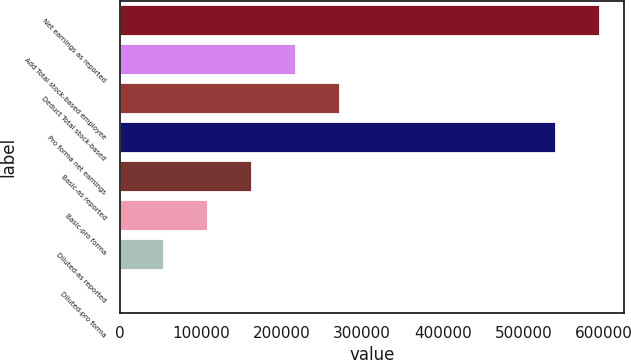<chart> <loc_0><loc_0><loc_500><loc_500><bar_chart><fcel>Net earnings as reported<fcel>Add Total stock-based employee<fcel>Deduct Total stock-based<fcel>Pro forma net earnings<fcel>Basic-as reported<fcel>Basic-pro forma<fcel>Diluted-as reported<fcel>Diluted-pro forma<nl><fcel>595021<fcel>218054<fcel>272566<fcel>540508<fcel>163541<fcel>109029<fcel>54516<fcel>3.48<nl></chart> 